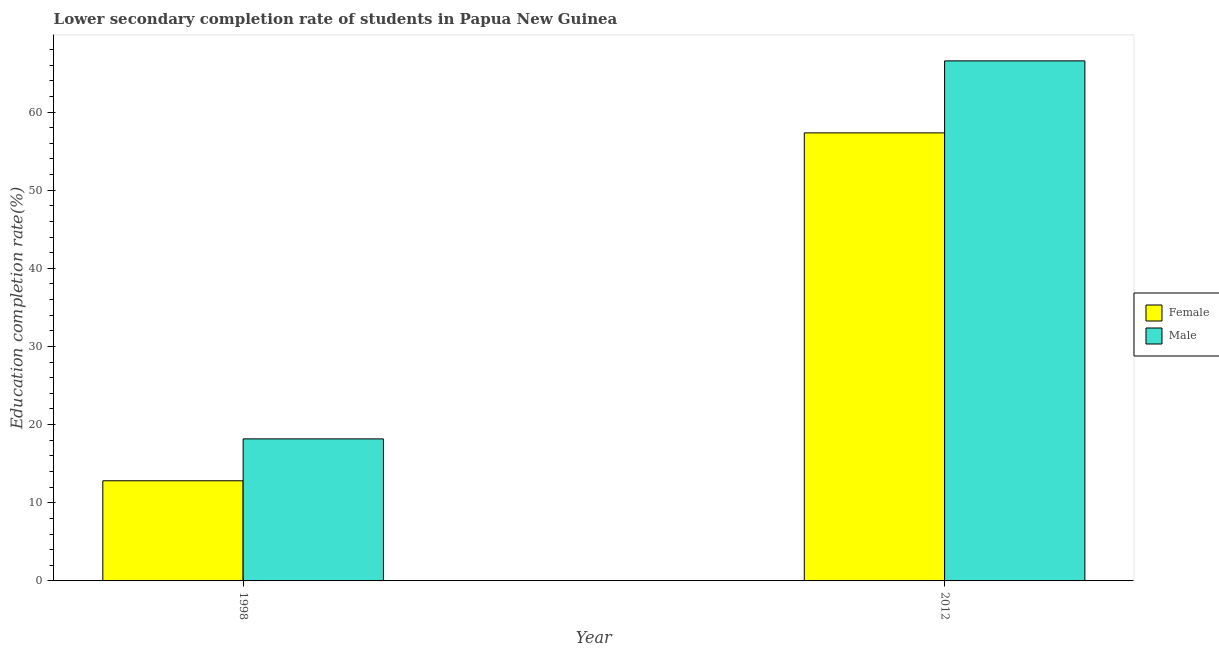Are the number of bars on each tick of the X-axis equal?
Keep it short and to the point. Yes. In how many cases, is the number of bars for a given year not equal to the number of legend labels?
Keep it short and to the point. 0. What is the education completion rate of male students in 1998?
Offer a very short reply. 18.18. Across all years, what is the maximum education completion rate of female students?
Your answer should be very brief. 57.33. Across all years, what is the minimum education completion rate of male students?
Keep it short and to the point. 18.18. In which year was the education completion rate of male students maximum?
Offer a terse response. 2012. In which year was the education completion rate of female students minimum?
Make the answer very short. 1998. What is the total education completion rate of male students in the graph?
Provide a succinct answer. 84.72. What is the difference between the education completion rate of female students in 1998 and that in 2012?
Ensure brevity in your answer.  -44.52. What is the difference between the education completion rate of male students in 2012 and the education completion rate of female students in 1998?
Offer a terse response. 48.37. What is the average education completion rate of female students per year?
Your answer should be compact. 35.07. What is the ratio of the education completion rate of female students in 1998 to that in 2012?
Your response must be concise. 0.22. What does the 2nd bar from the right in 1998 represents?
Your answer should be very brief. Female. How many bars are there?
Your answer should be compact. 4. Are all the bars in the graph horizontal?
Offer a very short reply. No. What is the difference between two consecutive major ticks on the Y-axis?
Offer a very short reply. 10. Are the values on the major ticks of Y-axis written in scientific E-notation?
Give a very brief answer. No. Does the graph contain grids?
Your answer should be compact. No. How many legend labels are there?
Provide a short and direct response. 2. How are the legend labels stacked?
Your answer should be compact. Vertical. What is the title of the graph?
Your answer should be compact. Lower secondary completion rate of students in Papua New Guinea. What is the label or title of the X-axis?
Keep it short and to the point. Year. What is the label or title of the Y-axis?
Your answer should be very brief. Education completion rate(%). What is the Education completion rate(%) of Female in 1998?
Offer a terse response. 12.82. What is the Education completion rate(%) of Male in 1998?
Provide a succinct answer. 18.18. What is the Education completion rate(%) of Female in 2012?
Give a very brief answer. 57.33. What is the Education completion rate(%) of Male in 2012?
Your response must be concise. 66.55. Across all years, what is the maximum Education completion rate(%) of Female?
Provide a succinct answer. 57.33. Across all years, what is the maximum Education completion rate(%) in Male?
Give a very brief answer. 66.55. Across all years, what is the minimum Education completion rate(%) of Female?
Provide a succinct answer. 12.82. Across all years, what is the minimum Education completion rate(%) of Male?
Your answer should be very brief. 18.18. What is the total Education completion rate(%) in Female in the graph?
Provide a short and direct response. 70.15. What is the total Education completion rate(%) of Male in the graph?
Ensure brevity in your answer.  84.72. What is the difference between the Education completion rate(%) of Female in 1998 and that in 2012?
Provide a succinct answer. -44.52. What is the difference between the Education completion rate(%) of Male in 1998 and that in 2012?
Your answer should be very brief. -48.37. What is the difference between the Education completion rate(%) of Female in 1998 and the Education completion rate(%) of Male in 2012?
Your response must be concise. -53.73. What is the average Education completion rate(%) of Female per year?
Make the answer very short. 35.07. What is the average Education completion rate(%) in Male per year?
Your answer should be very brief. 42.36. In the year 1998, what is the difference between the Education completion rate(%) in Female and Education completion rate(%) in Male?
Ensure brevity in your answer.  -5.36. In the year 2012, what is the difference between the Education completion rate(%) in Female and Education completion rate(%) in Male?
Give a very brief answer. -9.21. What is the ratio of the Education completion rate(%) of Female in 1998 to that in 2012?
Ensure brevity in your answer.  0.22. What is the ratio of the Education completion rate(%) of Male in 1998 to that in 2012?
Make the answer very short. 0.27. What is the difference between the highest and the second highest Education completion rate(%) of Female?
Make the answer very short. 44.52. What is the difference between the highest and the second highest Education completion rate(%) of Male?
Provide a short and direct response. 48.37. What is the difference between the highest and the lowest Education completion rate(%) in Female?
Give a very brief answer. 44.52. What is the difference between the highest and the lowest Education completion rate(%) of Male?
Offer a terse response. 48.37. 